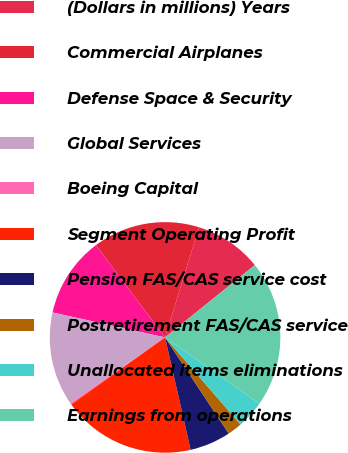<chart> <loc_0><loc_0><loc_500><loc_500><pie_chart><fcel>(Dollars in millions) Years<fcel>Commercial Airplanes<fcel>Defense Space & Security<fcel>Global Services<fcel>Boeing Capital<fcel>Segment Operating Profit<fcel>Pension FAS/CAS service cost<fcel>Postretirement FAS/CAS service<fcel>Unallocated items eliminations<fcel>Earnings from operations<nl><fcel>9.45%<fcel>14.99%<fcel>11.29%<fcel>13.14%<fcel>0.21%<fcel>18.69%<fcel>5.75%<fcel>2.05%<fcel>3.9%<fcel>20.53%<nl></chart> 